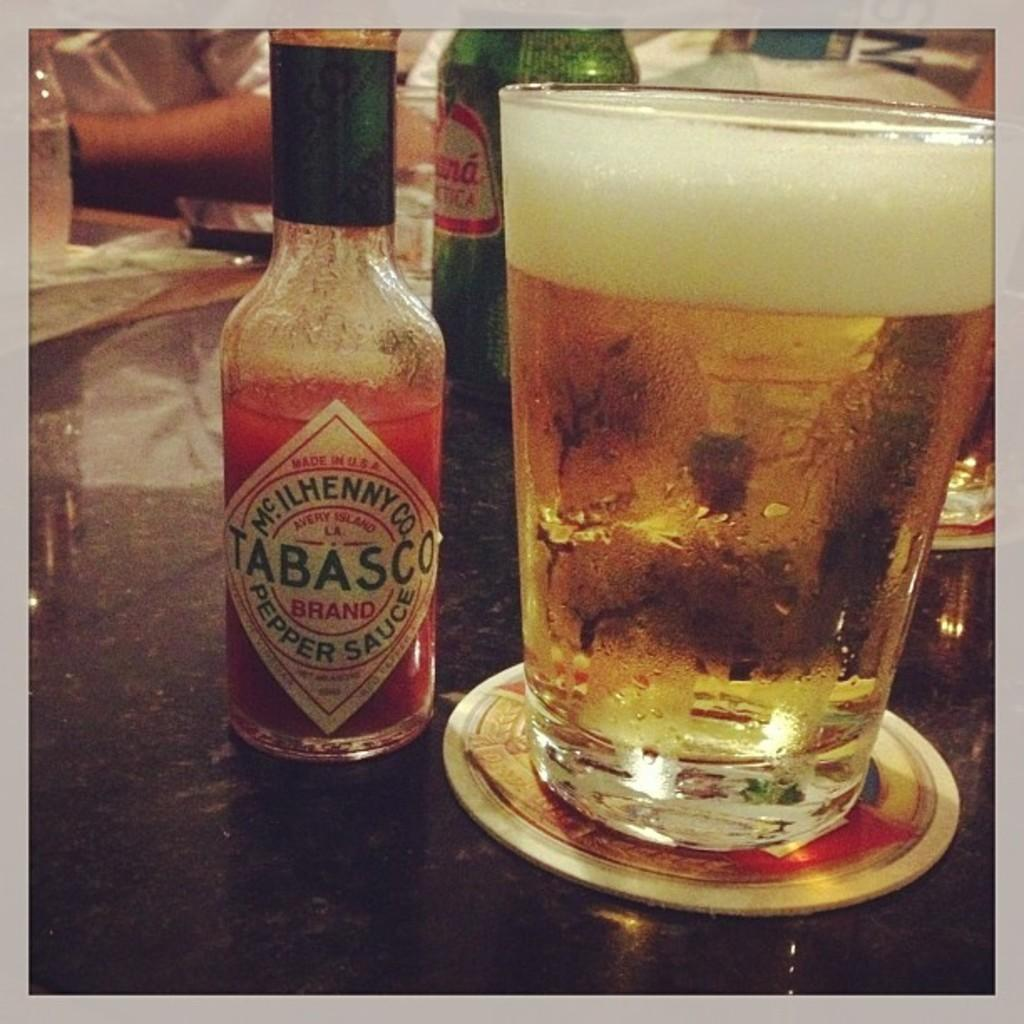<image>
Relay a brief, clear account of the picture shown. A bottle of Tabasco pepper sauce sits next to a glass of beer on a table. 